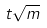Convert formula to latex. <formula><loc_0><loc_0><loc_500><loc_500>t \sqrt { m }</formula> 